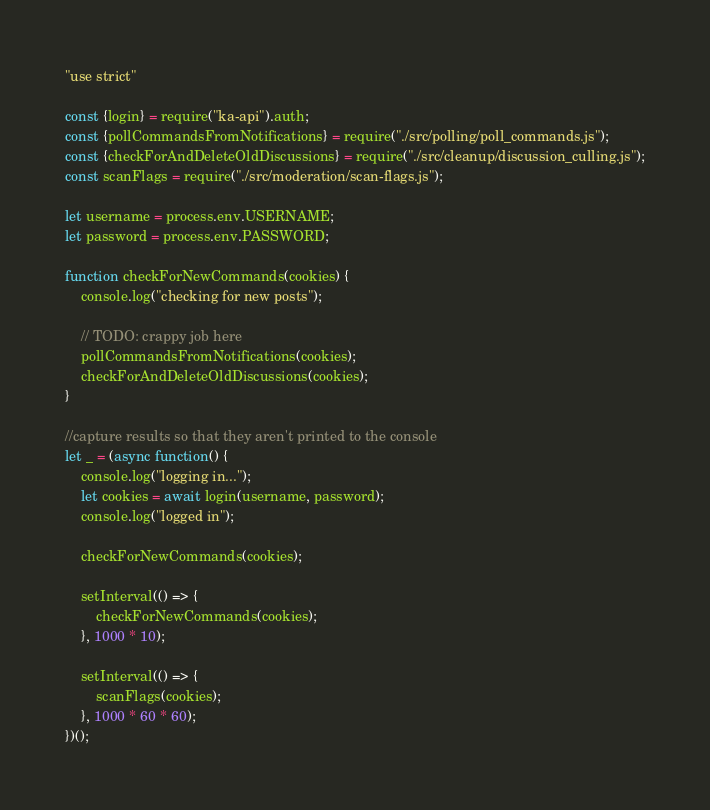<code> <loc_0><loc_0><loc_500><loc_500><_JavaScript_>"use strict"

const {login} = require("ka-api").auth;
const {pollCommandsFromNotifications} = require("./src/polling/poll_commands.js");
const {checkForAndDeleteOldDiscussions} = require("./src/cleanup/discussion_culling.js");
const scanFlags = require("./src/moderation/scan-flags.js");

let username = process.env.USERNAME;
let password = process.env.PASSWORD;

function checkForNewCommands(cookies) {
    console.log("checking for new posts");

    // TODO: crappy job here
    pollCommandsFromNotifications(cookies);
    checkForAndDeleteOldDiscussions(cookies);
}

//capture results so that they aren't printed to the console
let _ = (async function() {
    console.log("logging in...");
    let cookies = await login(username, password);
    console.log("logged in");

    checkForNewCommands(cookies);

    setInterval(() => {
        checkForNewCommands(cookies);
    }, 1000 * 10);

    setInterval(() => {
        scanFlags(cookies);
    }, 1000 * 60 * 60);
})();
</code> 